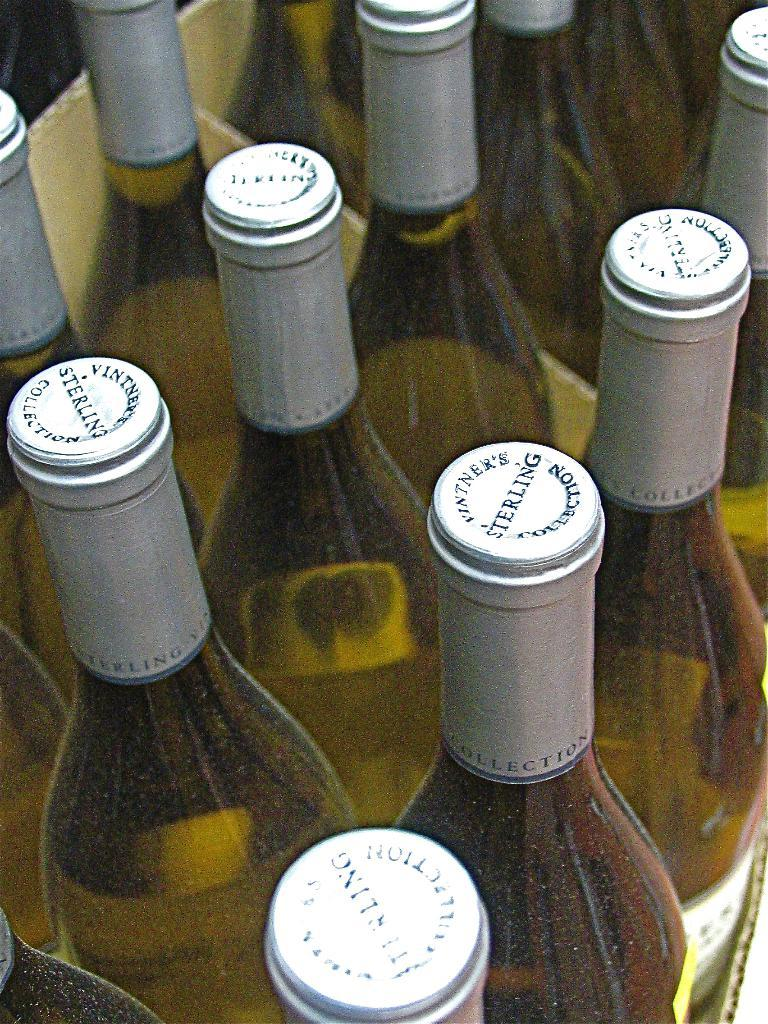<image>
Share a concise interpretation of the image provided. A close up photograph shows bottles of white wine.  The bottles bear a silver wrap with caps reading STERLING Vintner's Collection. 